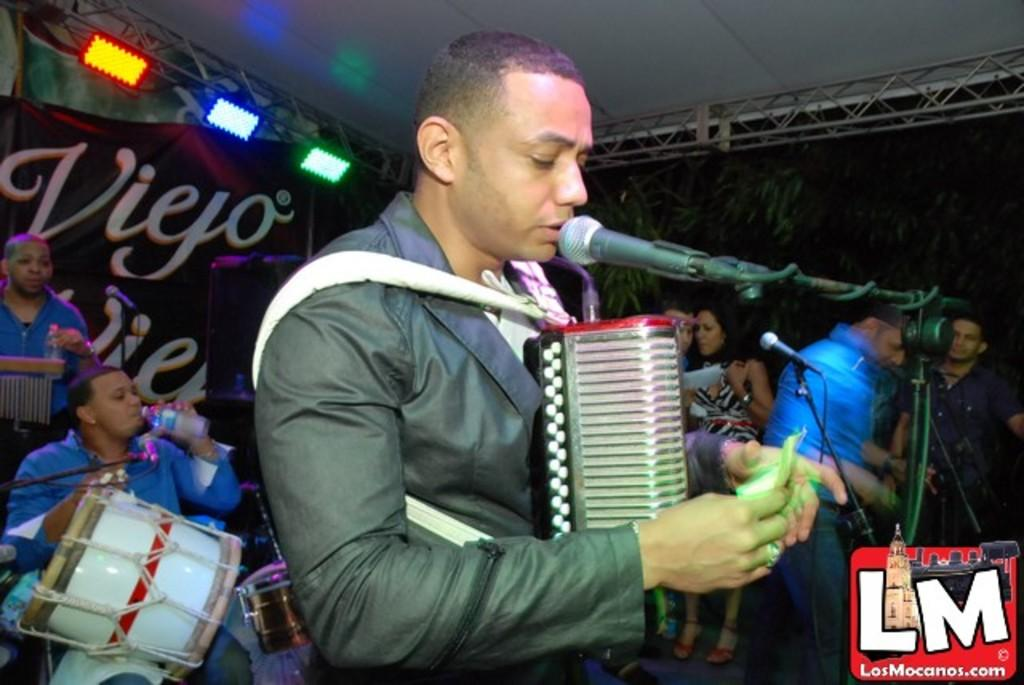What is the man in the image doing? The man is singing in the image. What is the man holding while singing? The man is holding a microphone. What is the man doing besides singing? The man is drinking water. How many people can be seen in the image? There are people in the image, but the exact number is not specified. What objects are present that are typically used for amplifying sound? There are microphones present in the image. What can be seen in the image that might be used by musicians? Musical instruments are visible in the image. What type of lighting is present in the image? There are lights in the image. What can be seen in the background of the image? There is a banner and trees in the background of the image. What type of hospital is visible in the image? There is no hospital present in the image. What is the man's need for a quarter in the image? There is no mention of a quarter or any need for one in the image. 